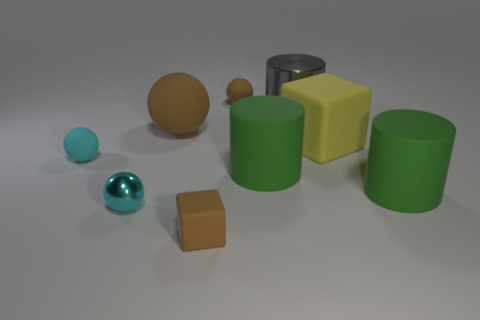What could be the purpose of this collection of objects? This collection of objects could serve a variety of purposes. It could be a simple 3D rendering intended to demonstrate different shapes and colors, often used in educational settings. Alternatively, it may be part of a virtual environment for a video game or simulation exercise, where the objects can be interacted with or could represent items to be collected or obstacles to navigate around. 